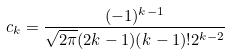<formula> <loc_0><loc_0><loc_500><loc_500>c _ { k } = \frac { ( - 1 ) ^ { k - 1 } } { \sqrt { 2 \pi } ( 2 k - 1 ) ( k - 1 ) ! 2 ^ { k - 2 } }</formula> 